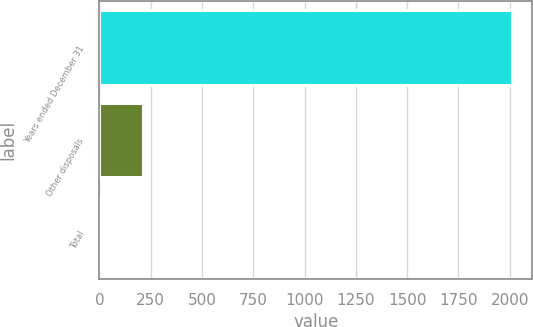Convert chart. <chart><loc_0><loc_0><loc_500><loc_500><bar_chart><fcel>Years ended December 31<fcel>Other disposals<fcel>Total<nl><fcel>2009<fcel>212.6<fcel>13<nl></chart> 